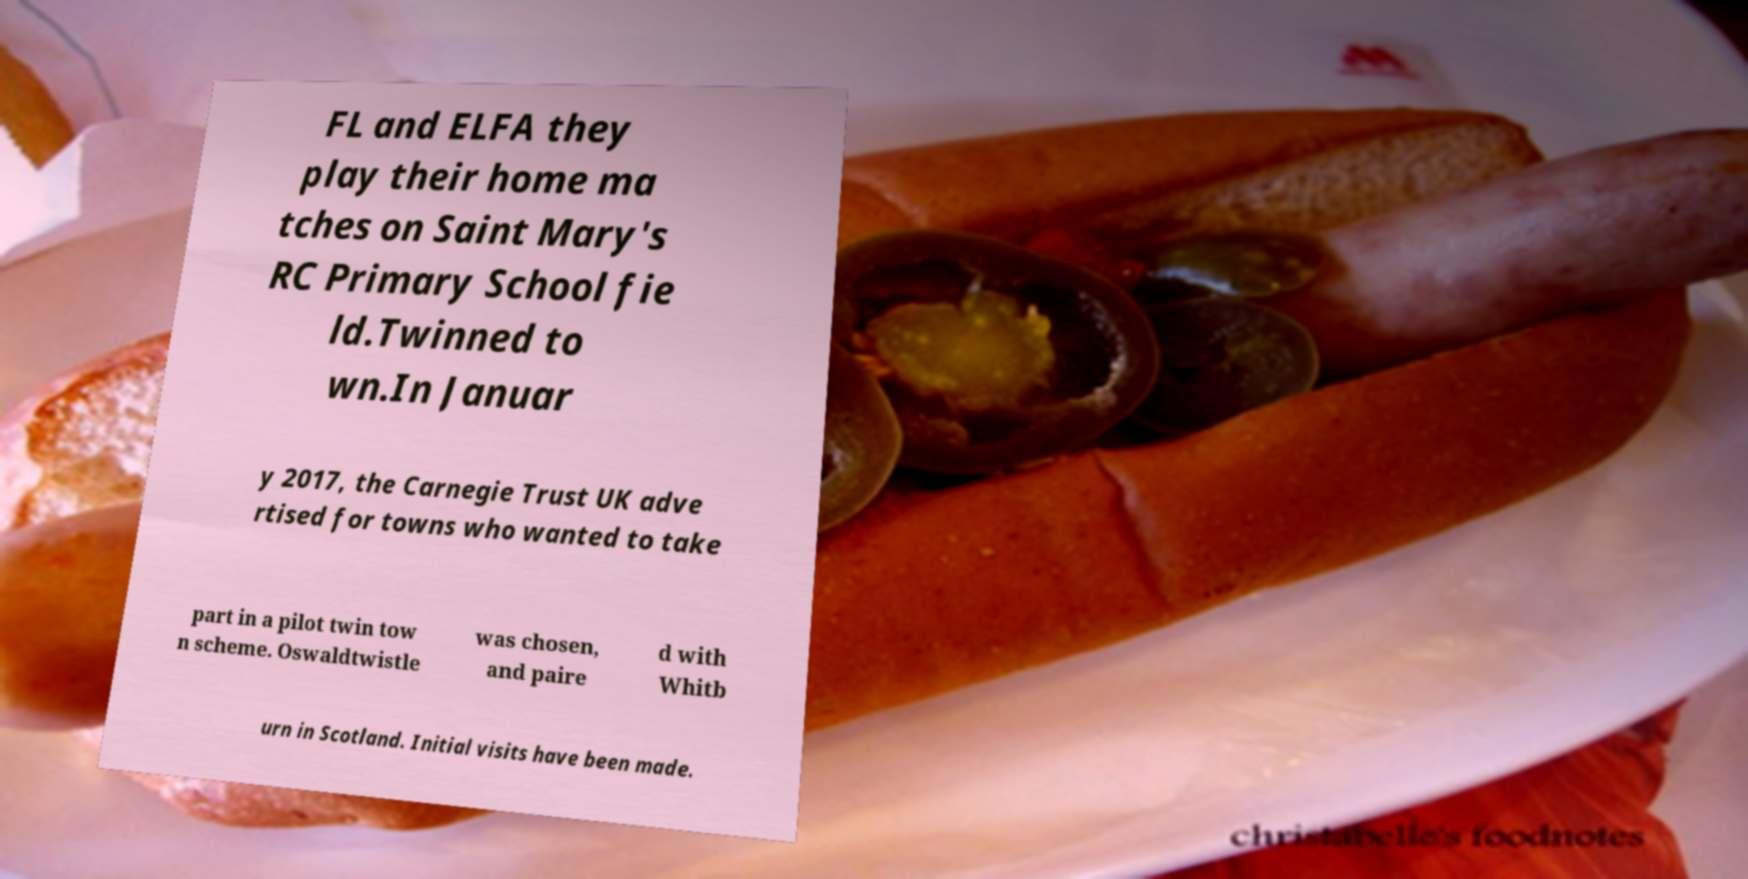Could you assist in decoding the text presented in this image and type it out clearly? FL and ELFA they play their home ma tches on Saint Mary's RC Primary School fie ld.Twinned to wn.In Januar y 2017, the Carnegie Trust UK adve rtised for towns who wanted to take part in a pilot twin tow n scheme. Oswaldtwistle was chosen, and paire d with Whitb urn in Scotland. Initial visits have been made. 